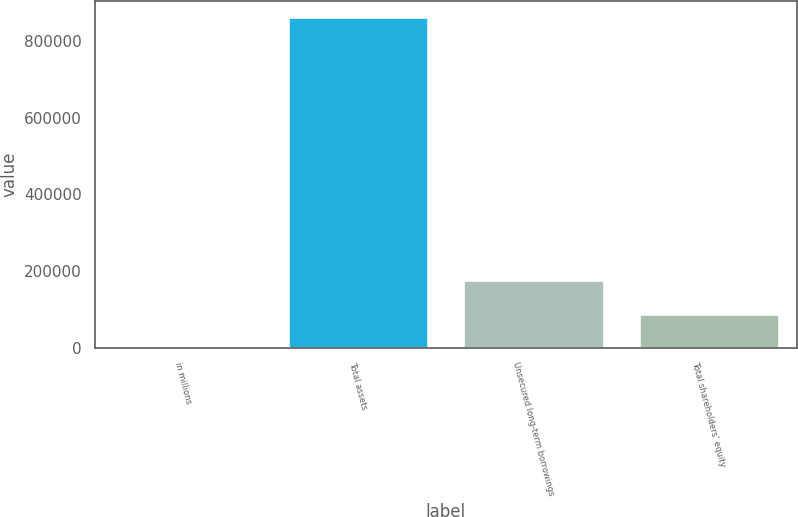<chart> <loc_0><loc_0><loc_500><loc_500><bar_chart><fcel>in millions<fcel>Total assets<fcel>Unsecured long-term borrowings<fcel>Total shareholders' equity<nl><fcel>2015<fcel>861395<fcel>175422<fcel>87953<nl></chart> 